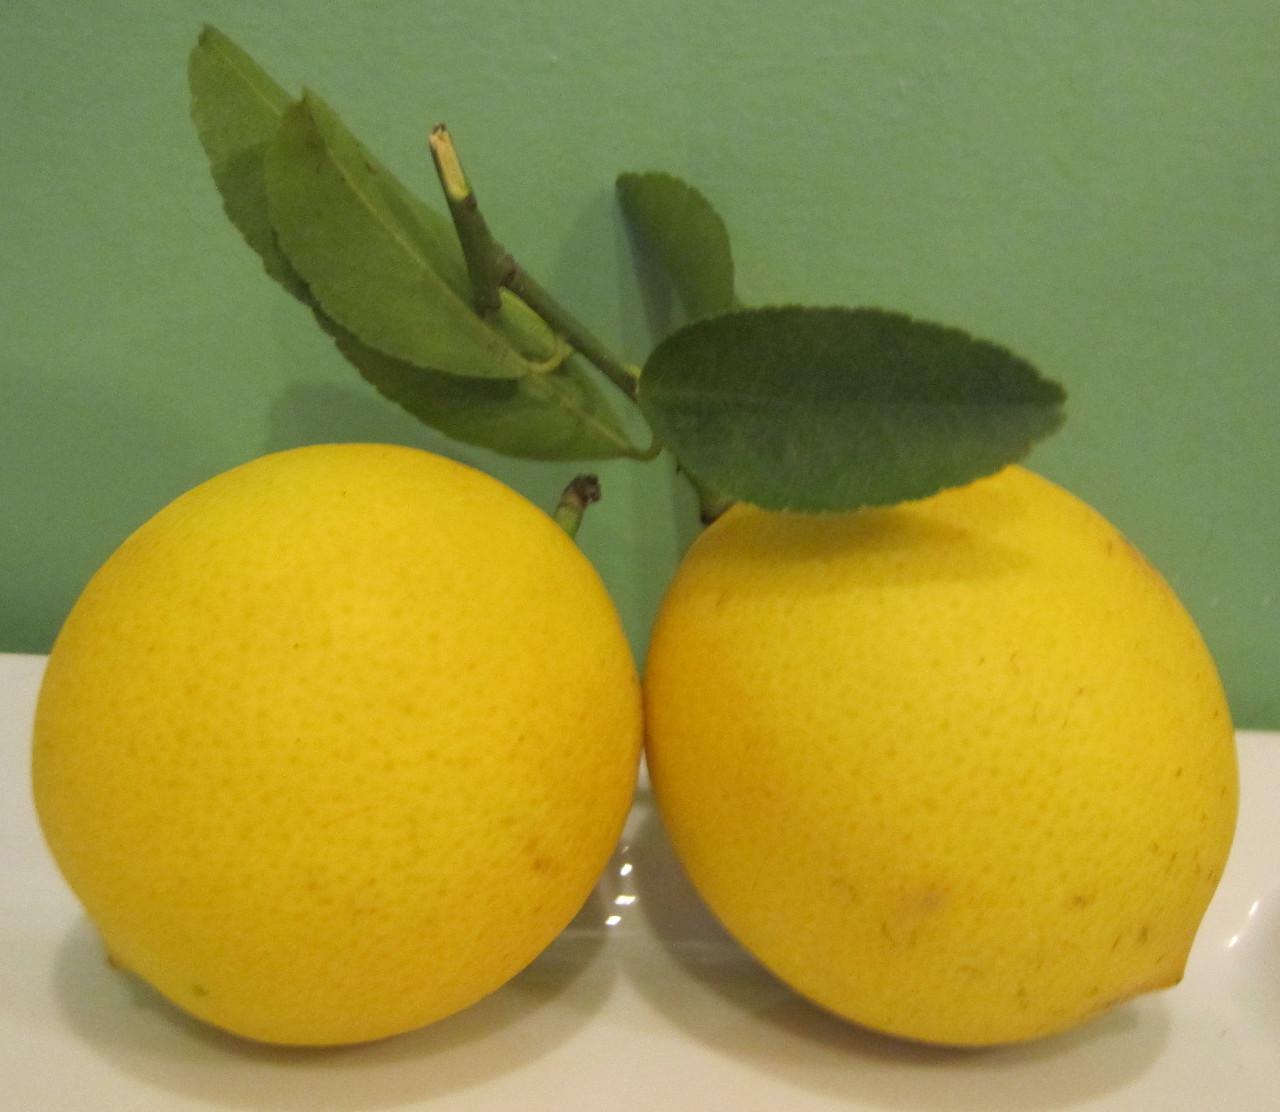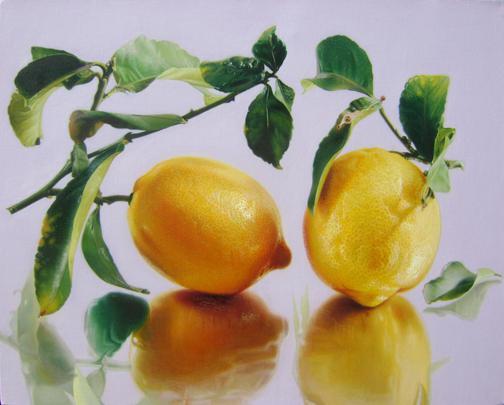The first image is the image on the left, the second image is the image on the right. For the images shown, is this caption "All of the lemons are connected to the same branch" true? Answer yes or no. No. 